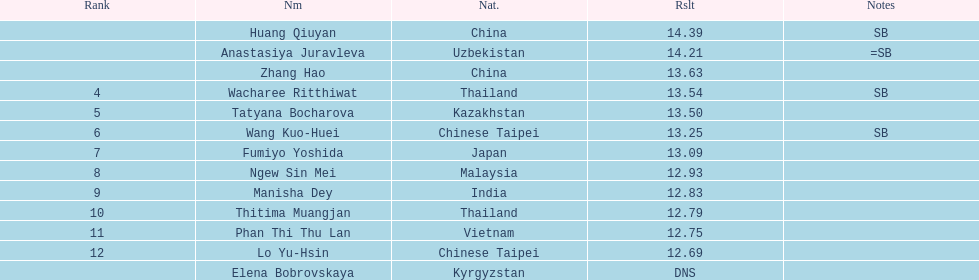What was the average result of the top three jumpers? 14.08. 